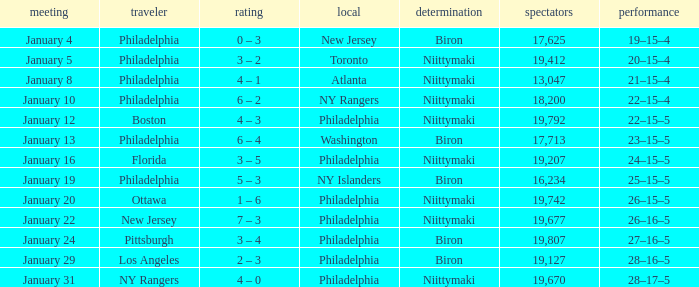Which team was the visitor on January 10? Philadelphia. 